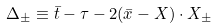Convert formula to latex. <formula><loc_0><loc_0><loc_500><loc_500>\Delta _ { \pm } \equiv \bar { t } - \tau - 2 ( \bar { x } - X ) \cdot X _ { \pm }</formula> 